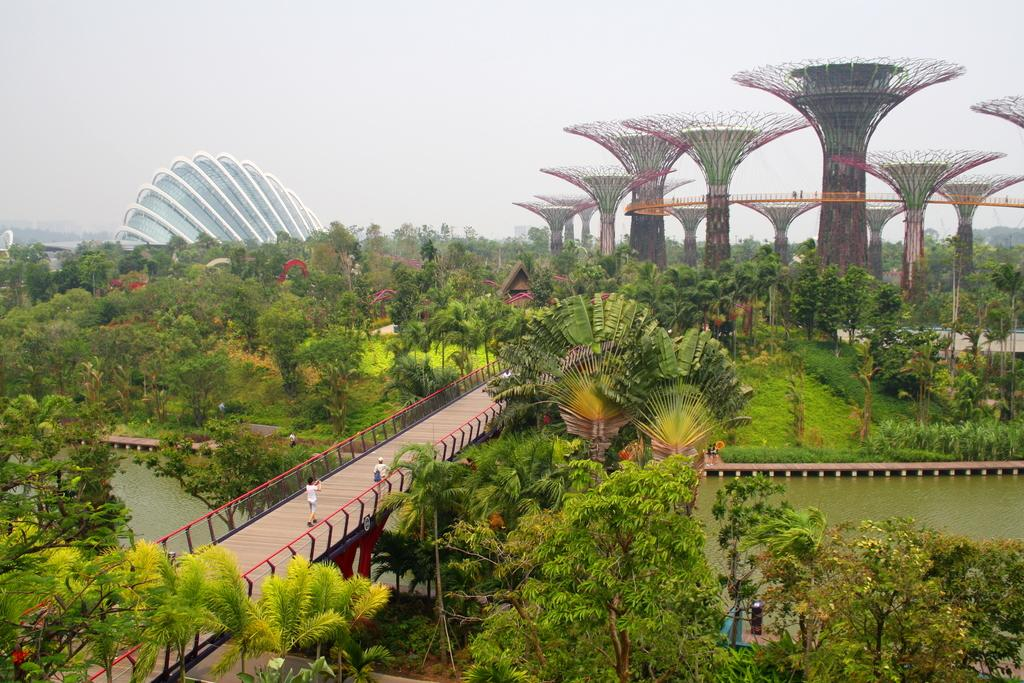What type of area is depicted in the image? There is a garden area in the image. What can be found in the garden area? There are trees, plants, a bridge, and people walking through a walkway in the garden area. What is the condition of the sky in the image? The sky is clear in the image. How many cows are grazing in the garden area in the image? There are no cows present in the garden area in the image. What type of neck accessory is being worn by the trees in the image? Trees do not wear neck accessories, as they are plants and not people. 